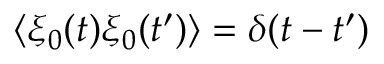<formula> <loc_0><loc_0><loc_500><loc_500>\langle \xi _ { 0 } ( t ) \xi _ { 0 } ( t ^ { \prime } ) \rangle = \delta ( t - t ^ { \prime } )</formula> 